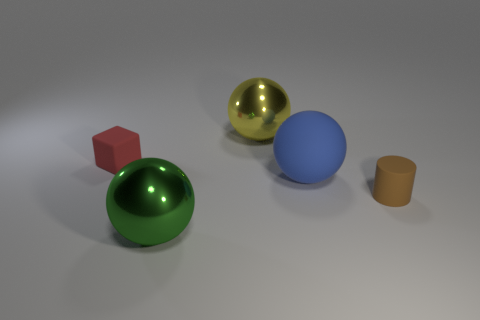Subtract all green balls. How many balls are left? 2 Subtract all green spheres. How many spheres are left? 2 Subtract 1 cylinders. How many cylinders are left? 0 Add 2 big green metal things. How many objects exist? 7 Subtract all red cylinders. How many yellow spheres are left? 1 Subtract all balls. How many objects are left? 2 Subtract all red cylinders. Subtract all gray balls. How many cylinders are left? 1 Subtract all yellow rubber blocks. Subtract all green spheres. How many objects are left? 4 Add 1 big rubber things. How many big rubber things are left? 2 Add 1 red rubber cubes. How many red rubber cubes exist? 2 